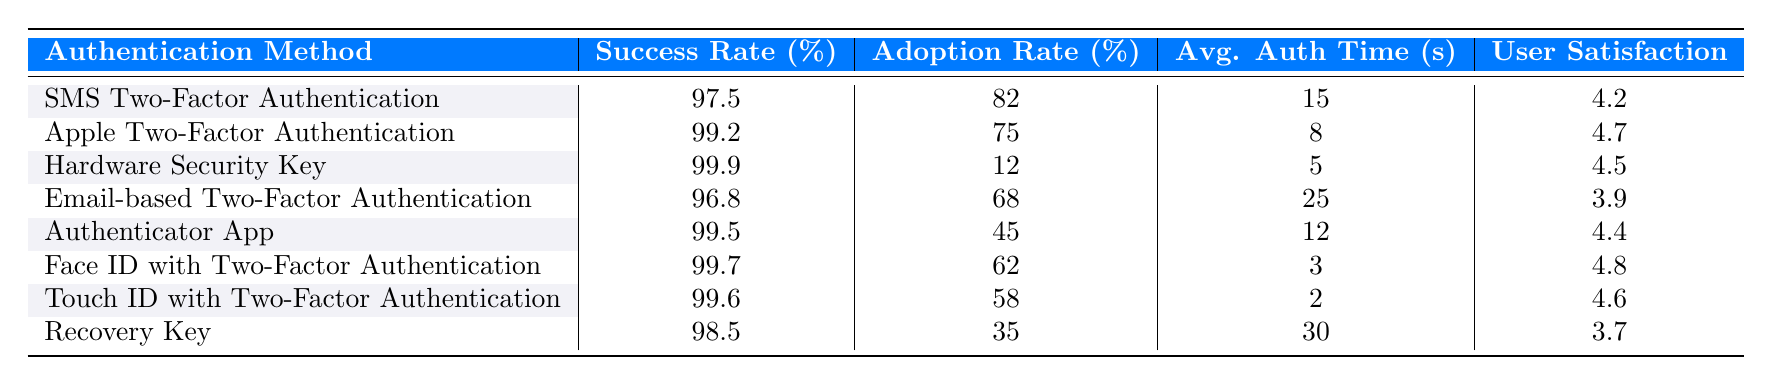What is the success rate of SMS Two-Factor Authentication? The success rate is directly listed in the table under the "Success Rate" column for SMS Two-Factor Authentication, which is 97.5%.
Answer: 97.5% Which authentication method has the highest success rate? By comparing the values in the "Success Rate" column, Hardware Security Key has the highest success rate at 99.9%.
Answer: 99.9% What is the average authentication time for the Apple Two-Factor Authentication method? The average authentication time is shown in the table under the "Avg. Auth Time" column for Apple Two-Factor Authentication, which is 8 seconds.
Answer: 8 seconds Is the user satisfaction score higher for Touch ID with Two-Factor Authentication than for Email-based Two-Factor Authentication? Comparing the "User Satisfaction" scores in the table, Touch ID has a score of 4.6, while Email-based has 3.9. Therefore, yes, Touch ID has a higher score.
Answer: Yes What is the difference in success rates between Hardware Security Key and Authenticator App? The success rate for Hardware Security Key is 99.9%, and for Authenticator App, it is 99.5%. The difference is 99.9 - 99.5 = 0.4%.
Answer: 0.4% Which authentication method has the lowest adoption rate? The adoption rates are 82%, 75%, 12%, 68%, 45%, 62%, 58%, and 35%. The lowest adoption rate is found for Hardware Security Key at 12%.
Answer: 12% What is the average user satisfaction score for the authentication methods listed in the table? Adding the user satisfaction scores: (4.2 + 4.7 + 4.5 + 3.9 + 4.4 + 4.8 + 4.6 + 3.7) = 34.8. There are 8 methods, so the average is 34.8 / 8 = 4.35.
Answer: 4.35 Is Face ID with Two-Factor Authentication more popular than Hardware Security Key? The adoption rates for Face ID and Hardware Security Key are compared: 62% for Face ID and 12% for Hardware Security Key. This indicates that Face ID is more popular.
Answer: Yes What is the total success rate of Email-based and Recovery Key combined? The success rates for Email-based (96.8%) and Recovery Key (98.5%) are added together: 96.8 + 98.5 = 195.3%.
Answer: 195.3% Which authentication method has the fastest average authentication time? The average authentication times for all methods show that Touch ID has the fastest time at 2 seconds.
Answer: 2 seconds 